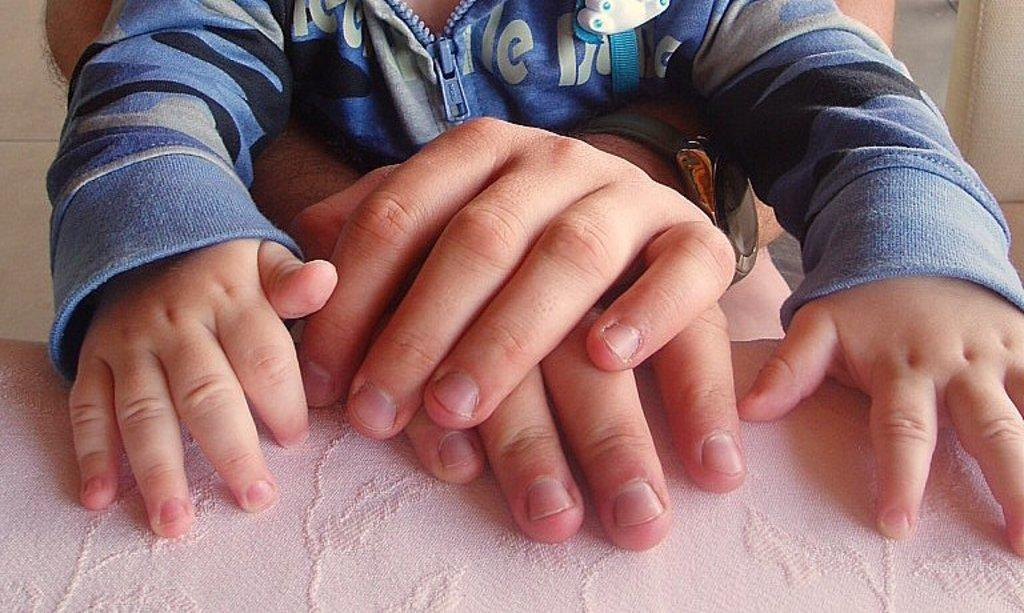What color is the cloth that is visible in the foreground of the image? The cloth in the foreground of the image is pink. What can be seen on the pink cloth? There are hands of a kid and a person on the cloth. Can you describe the hands on the cloth? The hands on the cloth belong to a kid and a person. What type of noise can be heard coming from the zipper in the image? There is no zipper present in the image, so it's not possible to determine what noise might be heard. 